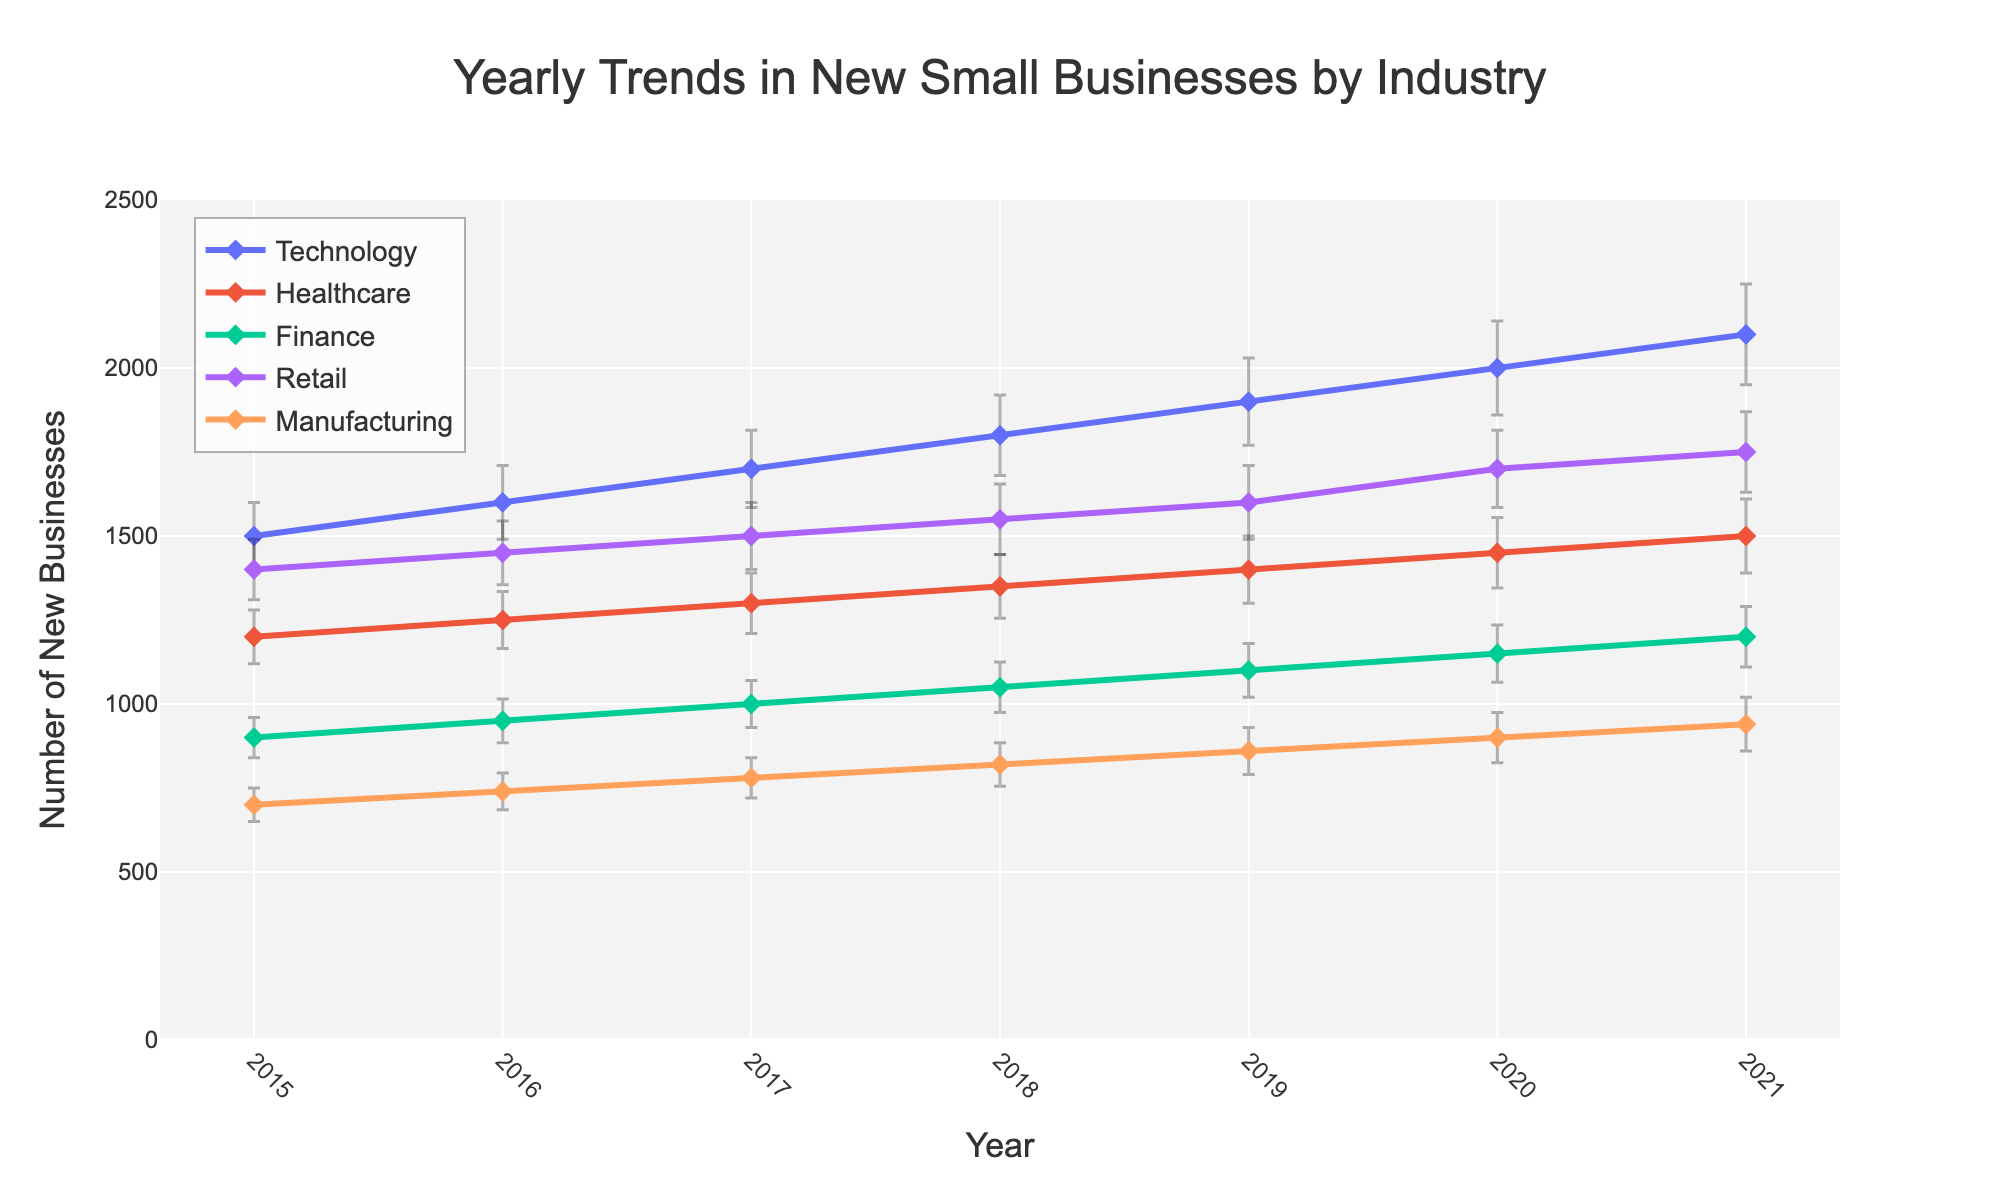what is the title of the plot? The title is prominently displayed at the top center of the plot, written in a larger font size compared to other texts.
Answer: Yearly Trends in New Small Businesses by Industry Which industry had the highest number of new businesses in 2021? To determine this, locate the data points for the year 2021 and compare the values across different industries. The Technology industry has the highest data point.
Answer: Technology What is the range of years displayed on the x-axis? The years can be seen on the x-axis of the plot. They span from 2015 to 2021.
Answer: 2015 to 2021 Which industry shows a steady increase in new businesses every year? Follow the line for each industry and identify which one rises consistently each year. The Technology industry shows a steady increase each year.
Answer: Technology What was the number of new retail businesses in 2018, including the error margin? Look at the plot point for Retail in 2018. The value is 1550 with an error margin of 105, so the range is from 1445 to 1655.
Answer: 1550 (Possible range: 1445 to 1655) Which industry had the smallest number of new businesses in 2016? Look at the 2016 data points and identify the lowest value, which is for the Manufacturing industry.
Answer: Manufacturing How did the number of new finance businesses change from 2015 to 2021? Locate the data points for Finance in 2015 and 2021. The values are 900 in 2015 and 1200 in 2021, showing an increase of 300.
Answer: Increased by 300 Between which consecutive years did the healthcare industry see the highest increase in new businesses? Calculate the difference in new business numbers for consecutive years and identify the highest increase. From 2019 to 2020, the increase is 50 (1400 to 1450).
Answer: From 2019 to 2020 Which industry has the most significant error margins in the data? Observe the length of error bars for different industries. The Technology industry has the most extended error bars, indicating the largest margins.
Answer: Technology Comparing 2017 and 2021, how much did the number of new businesses in manufacturing change? Look at the manufacturing data points for 2017 (780) and 2021 (940). Subtract 780 from 940 to find the change.
Answer: Increased by 160 